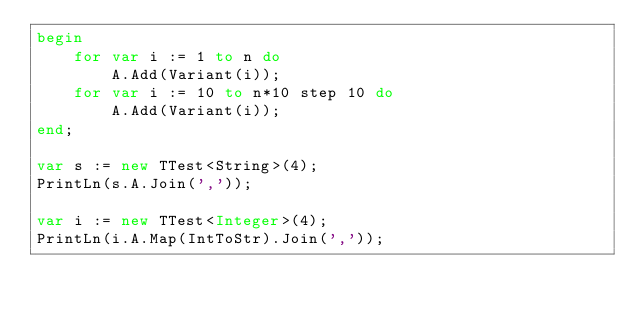<code> <loc_0><loc_0><loc_500><loc_500><_Pascal_>begin
    for var i := 1 to n do
        A.Add(Variant(i));
    for var i := 10 to n*10 step 10 do
        A.Add(Variant(i));
end;

var s := new TTest<String>(4);
PrintLn(s.A.Join(','));
       
var i := new TTest<Integer>(4);
PrintLn(i.A.Map(IntToStr).Join(','));
    
</code> 